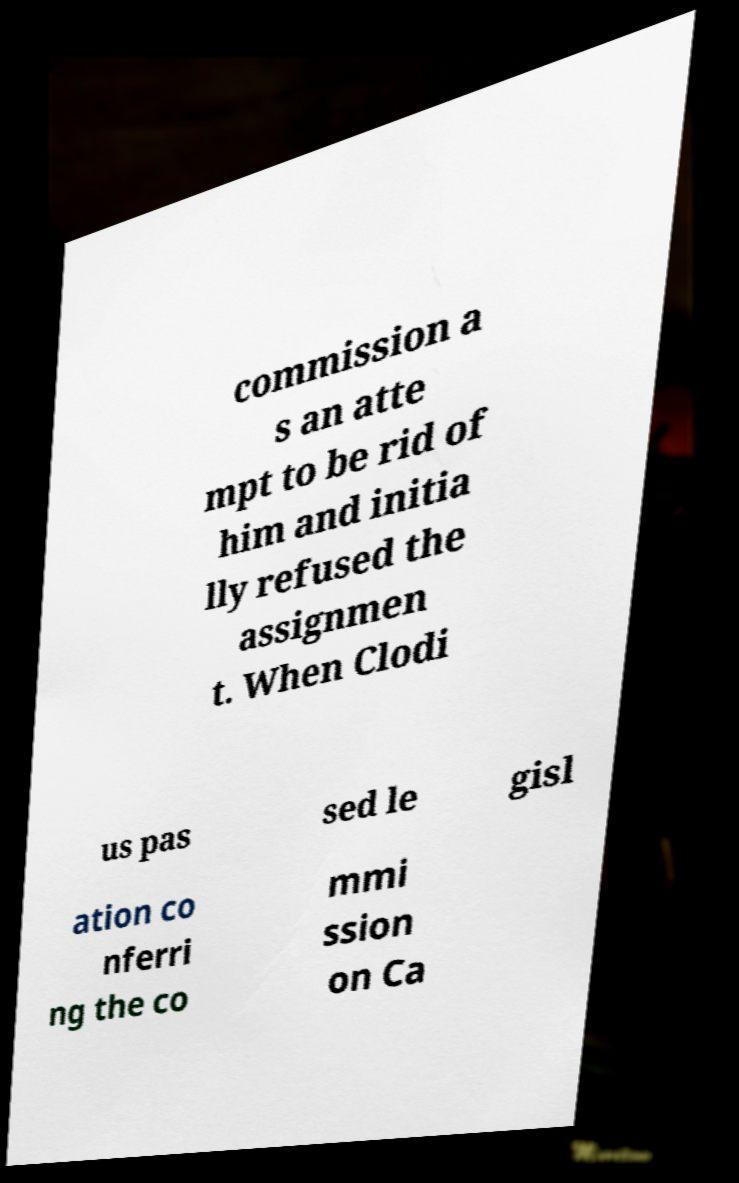Could you assist in decoding the text presented in this image and type it out clearly? commission a s an atte mpt to be rid of him and initia lly refused the assignmen t. When Clodi us pas sed le gisl ation co nferri ng the co mmi ssion on Ca 